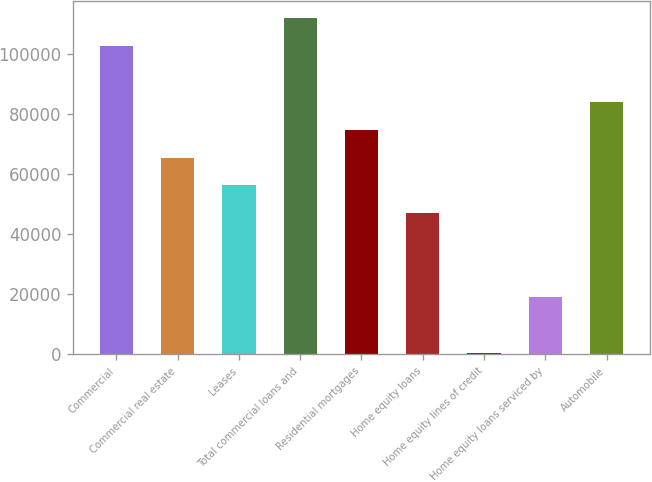Convert chart to OTSL. <chart><loc_0><loc_0><loc_500><loc_500><bar_chart><fcel>Commercial<fcel>Commercial real estate<fcel>Leases<fcel>Total commercial loans and<fcel>Residential mortgages<fcel>Home equity loans<fcel>Home equity lines of credit<fcel>Home equity loans serviced by<fcel>Automobile<nl><fcel>102696<fcel>65552<fcel>56266<fcel>111982<fcel>74838<fcel>46980<fcel>550<fcel>19122<fcel>84124<nl></chart> 